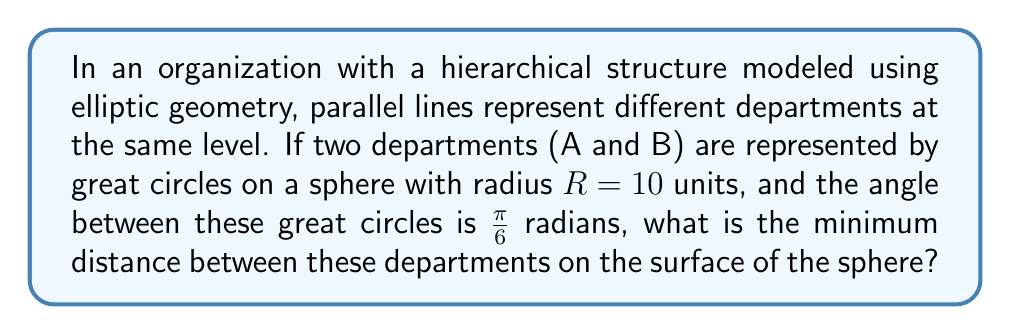Can you answer this question? To solve this problem, we'll follow these steps:

1) In elliptic geometry on a sphere, parallel lines are represented by great circles that intersect at two antipodal points.

2) The distance between two great circles on a sphere is measured along the perpendicular arc connecting them.

3) The formula for the minimum distance $d$ between two great circles with an angle $\theta$ between them on a sphere of radius $R$ is:

   $$d = R \arcsin(\sin(\frac{\theta}{2}))$$

4) In our case:
   $R = 10$ units
   $\theta = \frac{\pi}{6}$ radians

5) Substituting these values into the formula:

   $$d = 10 \arcsin(\sin(\frac{\pi}{12}))$$

6) Calculate $\sin(\frac{\pi}{12})$:
   $$\sin(\frac{\pi}{12}) \approx 0.2588$$

7) Apply arcsin:
   $$d = 10 \arcsin(0.2588) \approx 2.6180$$

8) Therefore, the minimum distance between the departments is approximately 2.6180 units on the surface of the sphere.

This model demonstrates how different departments at the same hierarchical level (represented by parallel lines in elliptic geometry) maintain a minimum separation, reflecting the distinct yet interconnected nature of organizational structures in HR management.
Answer: $2.6180$ units 